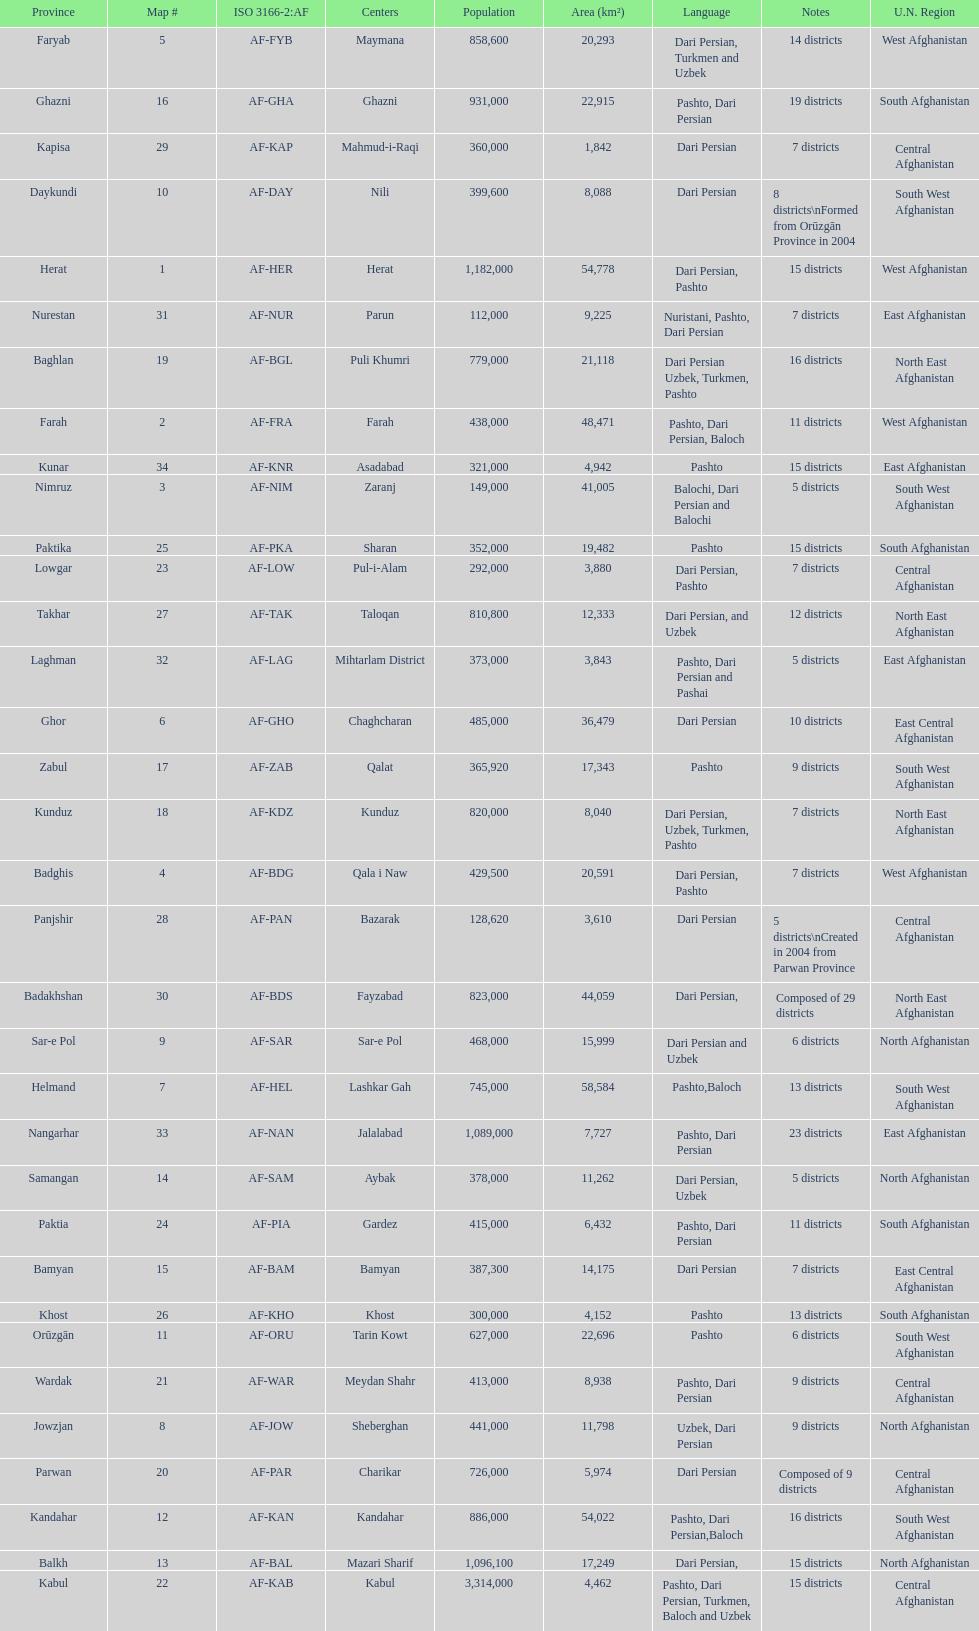How many provinces in afghanistan speak dari persian? 28. 